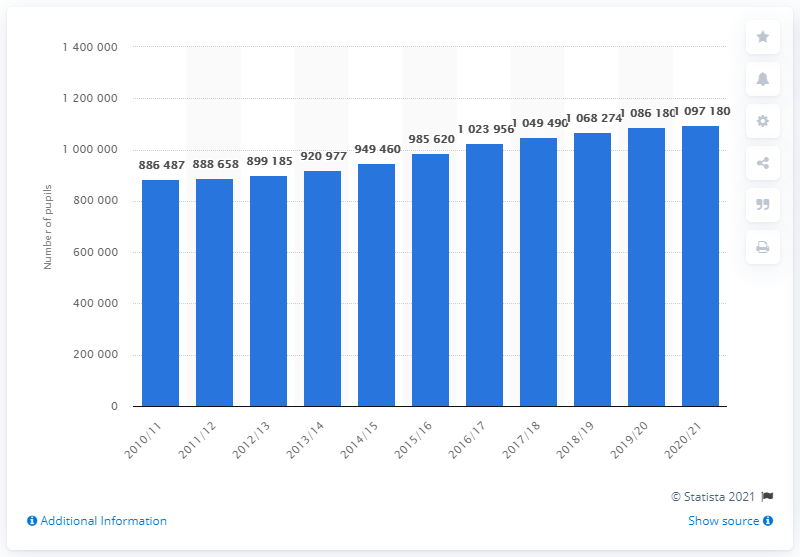Give some essential details in this illustration. In the 2010/2011 school year, a total of 886,487 pupils attended primary school. In the schoolyear 2020/21, a total of 109,7180 pupils attended primary school. 